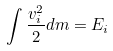Convert formula to latex. <formula><loc_0><loc_0><loc_500><loc_500>\int \frac { v _ { i } ^ { 2 } } { 2 } d m = E _ { i }</formula> 